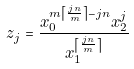Convert formula to latex. <formula><loc_0><loc_0><loc_500><loc_500>z _ { j } = \frac { x _ { 0 } ^ { m \left \lceil \frac { j n } { m } \right \rceil - j n } x _ { 2 } ^ { j } } { x _ { 1 } ^ { \left \lceil \frac { j n } { m } \right \rceil } }</formula> 